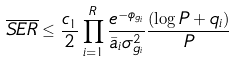<formula> <loc_0><loc_0><loc_500><loc_500>\overline { S E R } \leq \frac { c _ { 1 } } { 2 } \prod _ { i = 1 } ^ { R } \frac { e ^ { - \phi _ { g _ { i } } } } { \bar { a } _ { i } \sigma _ { g _ { i } } ^ { 2 } } \frac { ( \log { P } + q _ { i } ) } { P }</formula> 